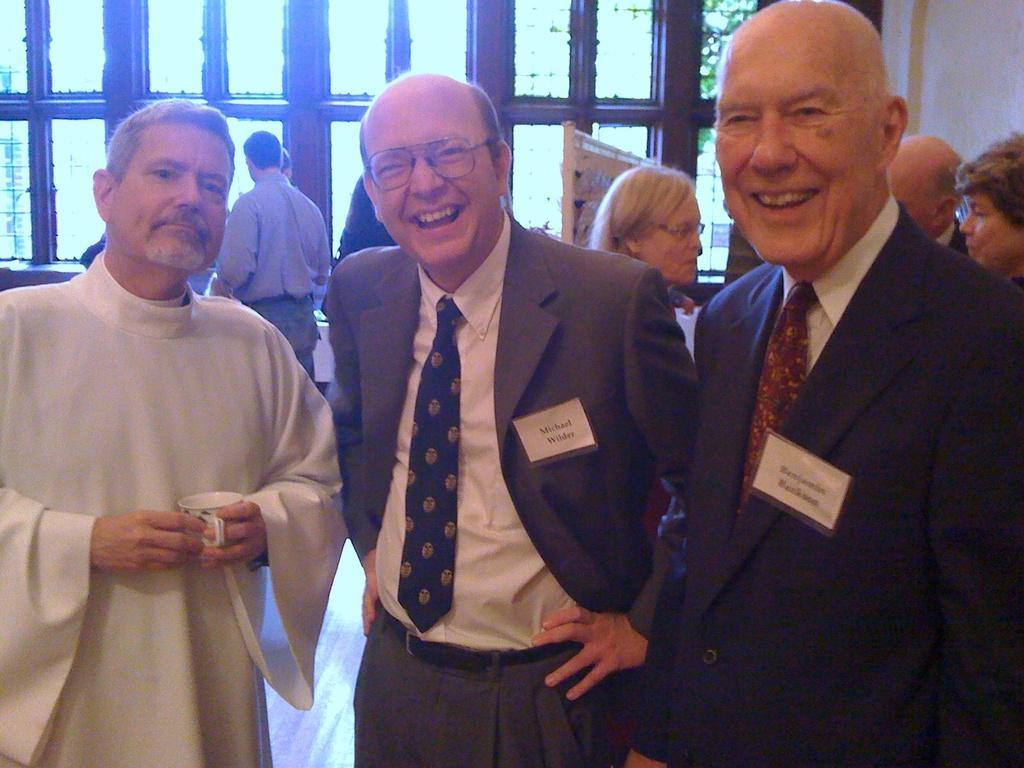In one or two sentences, can you explain what this image depicts? In the image we can see three men standing, wearing clothes and they are smiling. Behind them there are other people and some of them are wearing spectacles, and the left side man is holding a tea cup in hand. Here we can see a floor and the glass windows. 